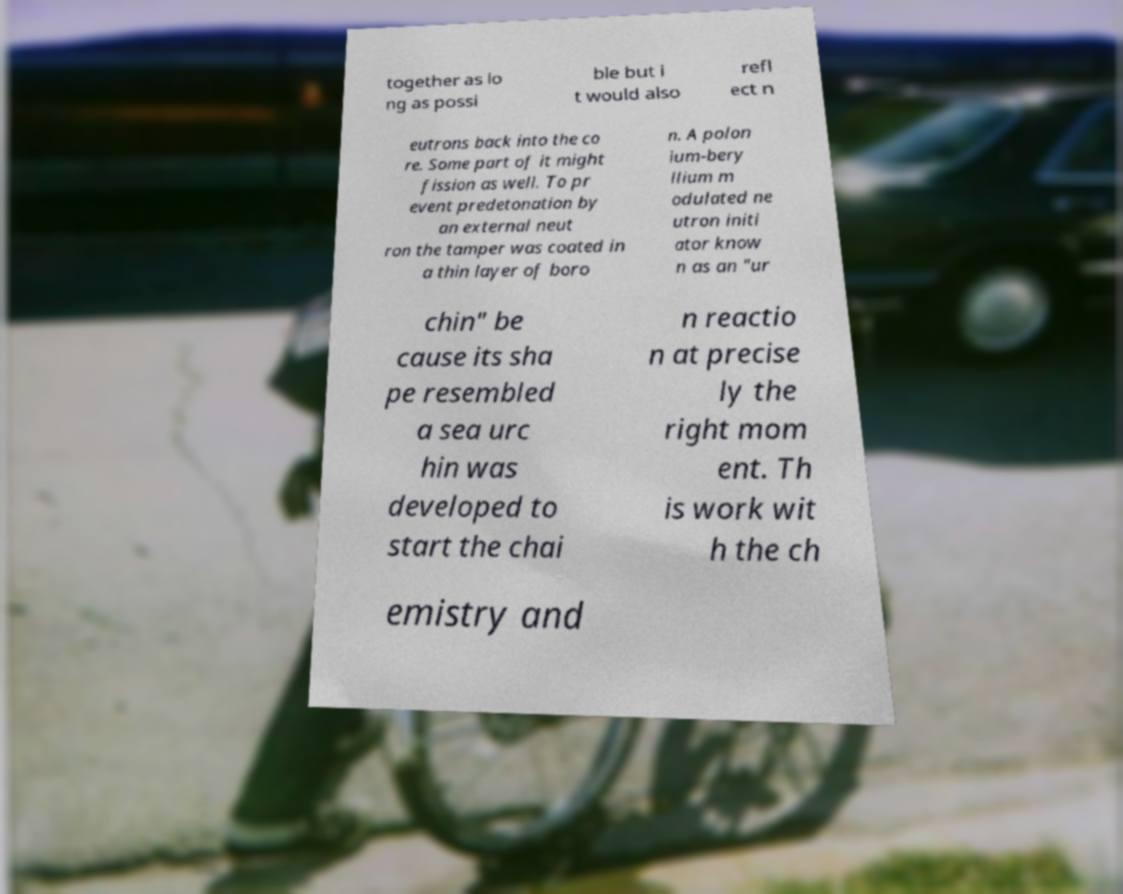I need the written content from this picture converted into text. Can you do that? together as lo ng as possi ble but i t would also refl ect n eutrons back into the co re. Some part of it might fission as well. To pr event predetonation by an external neut ron the tamper was coated in a thin layer of boro n. A polon ium-bery llium m odulated ne utron initi ator know n as an "ur chin" be cause its sha pe resembled a sea urc hin was developed to start the chai n reactio n at precise ly the right mom ent. Th is work wit h the ch emistry and 